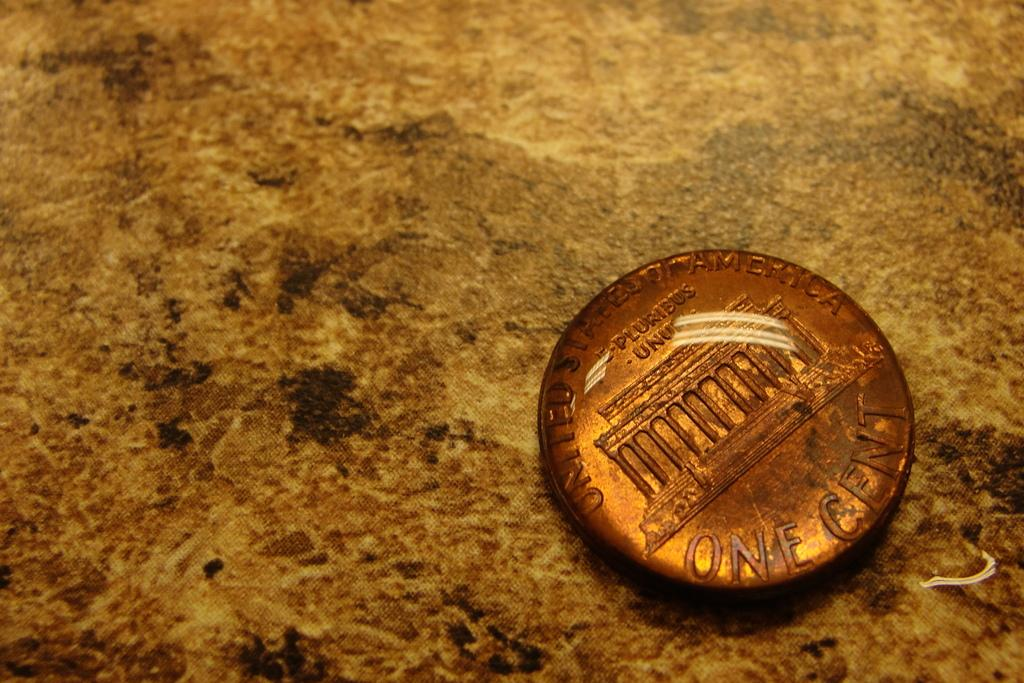<image>
Present a compact description of the photo's key features. the back of a UNITED STATES OF AMERICA one cent penny. 